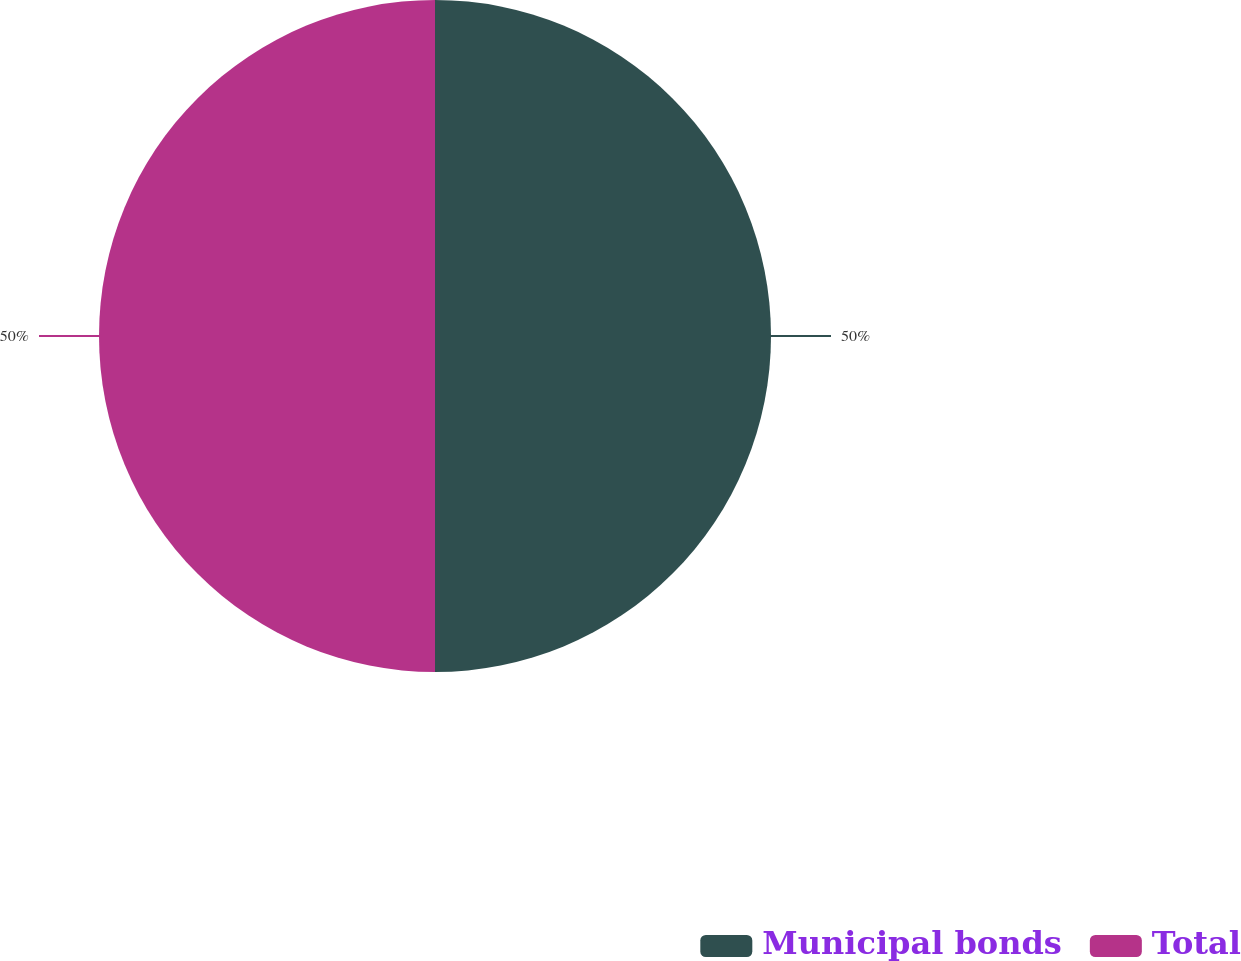<chart> <loc_0><loc_0><loc_500><loc_500><pie_chart><fcel>Municipal bonds<fcel>Total<nl><fcel>50.0%<fcel>50.0%<nl></chart> 